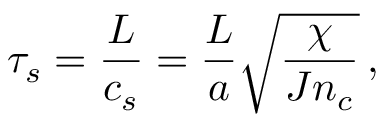<formula> <loc_0><loc_0><loc_500><loc_500>\tau _ { s } = \frac { L } { c _ { s } } = \frac { L } { a } \sqrt { \frac { \chi } { J n _ { c } } } \, ,</formula> 